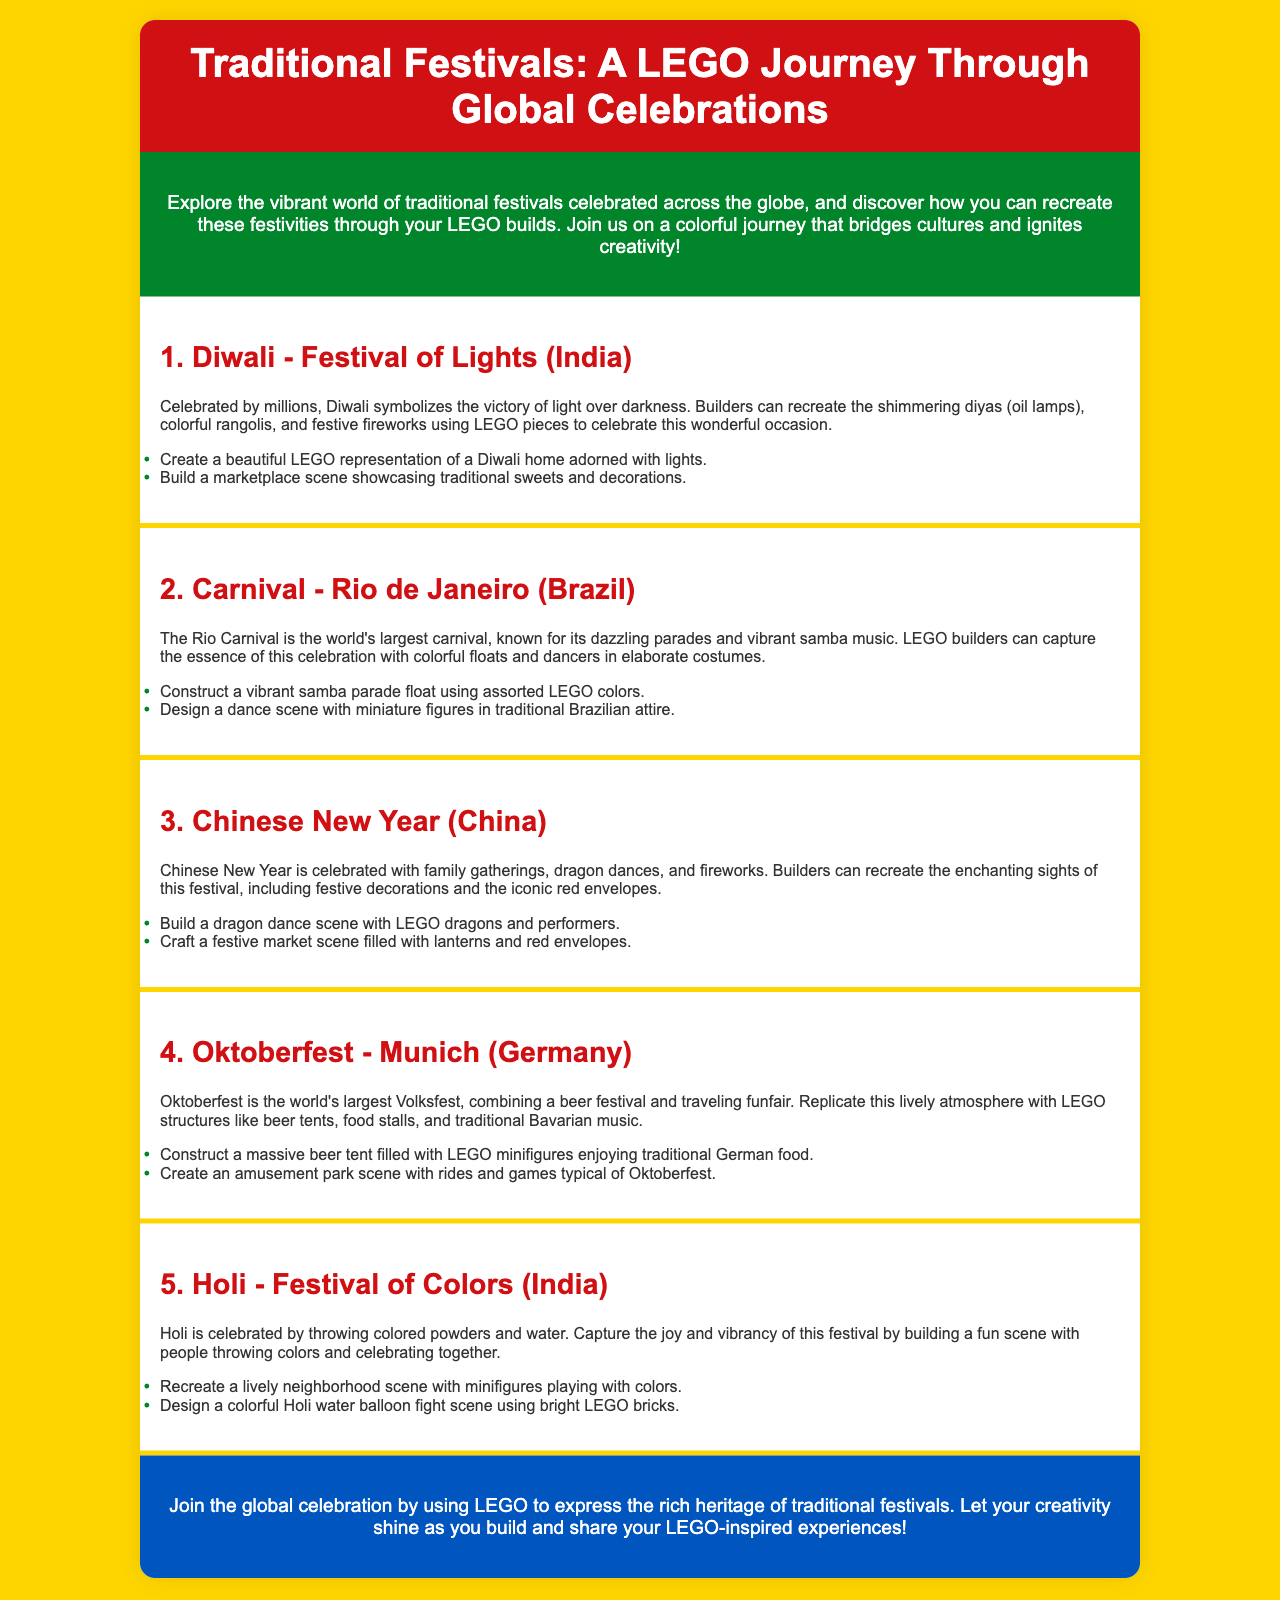What is the title of the brochure? The title of the brochure is prominently featured at the top of the document.
Answer: Traditional Festivals: A LEGO Journey Through Global Celebrations How many traditional festivals are highlighted in the brochure? The brochure lists five traditional festivals under their respective sections.
Answer: 5 Which festival is known as the Festival of Lights? The brochure specifically refers to Diwali in this context.
Answer: Diwali What is a key activity associated with Chinese New Year mentioned in the document? Dragon dances are highlighted as a significant part of the Chinese New Year celebrations.
Answer: Dragon dance What festival is associated with colorful powders and water? The brochure describes Holi as being celebrated with colorful powders and water.
Answer: Holi What type of scene can you build for the Oktoberfest festival? The document suggests constructing a massive beer tent filled with minifigures enjoying traditional German food.
Answer: Beer tent What is the main focus of the brochure? The brochure aims to inspire LEGO builders to recreate traditional festivals through their builds.
Answer: Cultural celebrations Which country celebrates the Carnival festival described in the brochure? The Carnival festival is specifically associated with Brazil as mentioned in the document.
Answer: Brazil What color is used for the background of the brochure? The background color is specified clearly in the style section of the document.
Answer: Yellow 